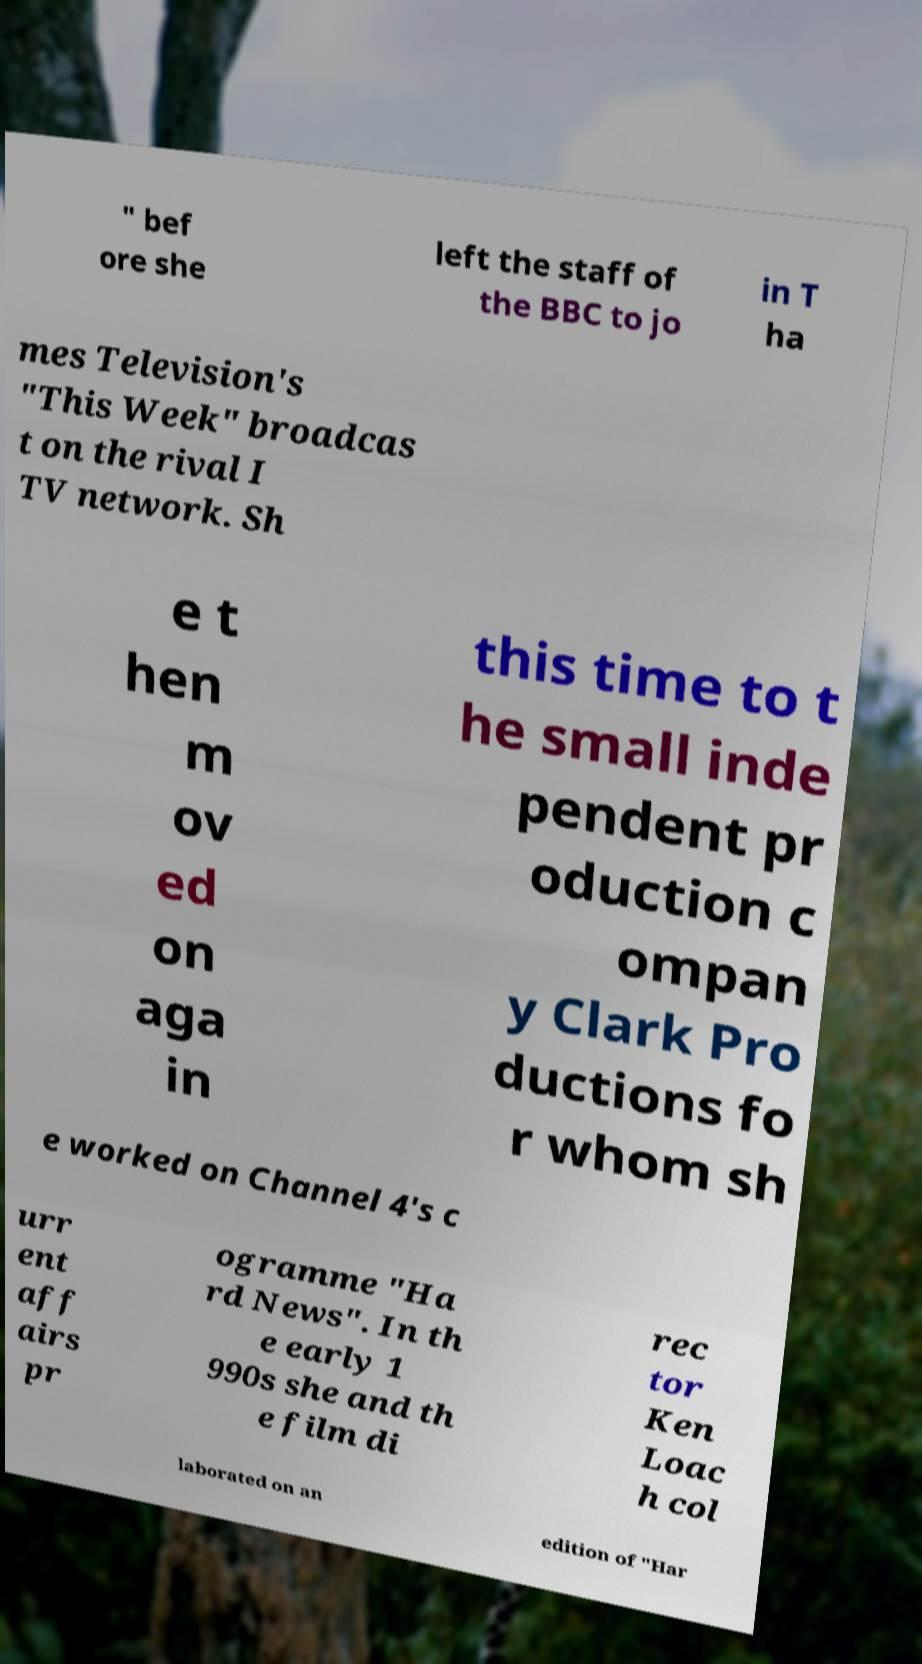There's text embedded in this image that I need extracted. Can you transcribe it verbatim? " bef ore she left the staff of the BBC to jo in T ha mes Television's "This Week" broadcas t on the rival I TV network. Sh e t hen m ov ed on aga in this time to t he small inde pendent pr oduction c ompan y Clark Pro ductions fo r whom sh e worked on Channel 4's c urr ent aff airs pr ogramme "Ha rd News". In th e early 1 990s she and th e film di rec tor Ken Loac h col laborated on an edition of "Har 